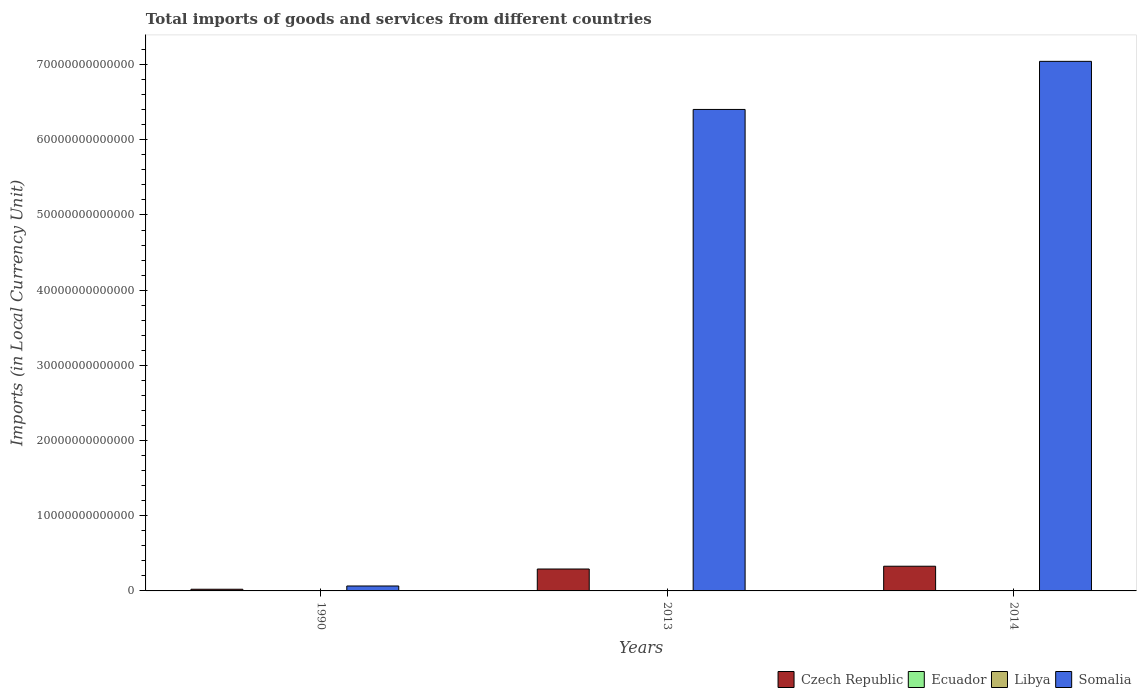How many groups of bars are there?
Provide a short and direct response. 3. Are the number of bars per tick equal to the number of legend labels?
Ensure brevity in your answer.  Yes. In how many cases, is the number of bars for a given year not equal to the number of legend labels?
Your response must be concise. 0. What is the Amount of goods and services imports in Libya in 2014?
Make the answer very short. 5.07e+1. Across all years, what is the maximum Amount of goods and services imports in Czech Republic?
Your answer should be compact. 3.29e+12. Across all years, what is the minimum Amount of goods and services imports in Libya?
Provide a succinct answer. 2.55e+09. In which year was the Amount of goods and services imports in Somalia maximum?
Offer a very short reply. 2014. What is the total Amount of goods and services imports in Czech Republic in the graph?
Your answer should be very brief. 6.42e+12. What is the difference between the Amount of goods and services imports in Somalia in 2013 and that in 2014?
Give a very brief answer. -6.40e+12. What is the difference between the Amount of goods and services imports in Libya in 2014 and the Amount of goods and services imports in Ecuador in 2013?
Provide a short and direct response. 2.08e+1. What is the average Amount of goods and services imports in Ecuador per year?
Provide a succinct answer. 2.12e+1. In the year 2013, what is the difference between the Amount of goods and services imports in Czech Republic and Amount of goods and services imports in Libya?
Provide a succinct answer. 2.86e+12. What is the ratio of the Amount of goods and services imports in Libya in 1990 to that in 2013?
Provide a short and direct response. 0.05. Is the Amount of goods and services imports in Libya in 2013 less than that in 2014?
Give a very brief answer. No. Is the difference between the Amount of goods and services imports in Czech Republic in 1990 and 2013 greater than the difference between the Amount of goods and services imports in Libya in 1990 and 2013?
Ensure brevity in your answer.  No. What is the difference between the highest and the second highest Amount of goods and services imports in Ecuador?
Your answer should be compact. 5.09e+08. What is the difference between the highest and the lowest Amount of goods and services imports in Somalia?
Ensure brevity in your answer.  6.98e+13. In how many years, is the Amount of goods and services imports in Libya greater than the average Amount of goods and services imports in Libya taken over all years?
Your response must be concise. 2. Is it the case that in every year, the sum of the Amount of goods and services imports in Czech Republic and Amount of goods and services imports in Libya is greater than the sum of Amount of goods and services imports in Ecuador and Amount of goods and services imports in Somalia?
Provide a succinct answer. Yes. What does the 3rd bar from the left in 2013 represents?
Offer a very short reply. Libya. What does the 2nd bar from the right in 2014 represents?
Your answer should be compact. Libya. How many bars are there?
Provide a short and direct response. 12. Are all the bars in the graph horizontal?
Offer a very short reply. No. How many years are there in the graph?
Your response must be concise. 3. What is the difference between two consecutive major ticks on the Y-axis?
Ensure brevity in your answer.  1.00e+13. Does the graph contain grids?
Provide a succinct answer. No. Where does the legend appear in the graph?
Offer a terse response. Bottom right. How many legend labels are there?
Provide a short and direct response. 4. What is the title of the graph?
Offer a terse response. Total imports of goods and services from different countries. Does "Syrian Arab Republic" appear as one of the legend labels in the graph?
Provide a succinct answer. No. What is the label or title of the Y-axis?
Make the answer very short. Imports (in Local Currency Unit). What is the Imports (in Local Currency Unit) in Czech Republic in 1990?
Your answer should be very brief. 2.23e+11. What is the Imports (in Local Currency Unit) in Ecuador in 1990?
Ensure brevity in your answer.  3.33e+09. What is the Imports (in Local Currency Unit) in Libya in 1990?
Keep it short and to the point. 2.55e+09. What is the Imports (in Local Currency Unit) of Somalia in 1990?
Keep it short and to the point. 6.56e+11. What is the Imports (in Local Currency Unit) in Czech Republic in 2013?
Keep it short and to the point. 2.91e+12. What is the Imports (in Local Currency Unit) in Ecuador in 2013?
Provide a short and direct response. 2.99e+1. What is the Imports (in Local Currency Unit) of Libya in 2013?
Make the answer very short. 5.40e+1. What is the Imports (in Local Currency Unit) in Somalia in 2013?
Your response must be concise. 6.40e+13. What is the Imports (in Local Currency Unit) in Czech Republic in 2014?
Provide a succinct answer. 3.29e+12. What is the Imports (in Local Currency Unit) in Ecuador in 2014?
Offer a terse response. 3.04e+1. What is the Imports (in Local Currency Unit) of Libya in 2014?
Your answer should be very brief. 5.07e+1. What is the Imports (in Local Currency Unit) in Somalia in 2014?
Ensure brevity in your answer.  7.04e+13. Across all years, what is the maximum Imports (in Local Currency Unit) in Czech Republic?
Give a very brief answer. 3.29e+12. Across all years, what is the maximum Imports (in Local Currency Unit) in Ecuador?
Your response must be concise. 3.04e+1. Across all years, what is the maximum Imports (in Local Currency Unit) of Libya?
Offer a terse response. 5.40e+1. Across all years, what is the maximum Imports (in Local Currency Unit) in Somalia?
Ensure brevity in your answer.  7.04e+13. Across all years, what is the minimum Imports (in Local Currency Unit) in Czech Republic?
Provide a short and direct response. 2.23e+11. Across all years, what is the minimum Imports (in Local Currency Unit) in Ecuador?
Make the answer very short. 3.33e+09. Across all years, what is the minimum Imports (in Local Currency Unit) in Libya?
Your answer should be compact. 2.55e+09. Across all years, what is the minimum Imports (in Local Currency Unit) of Somalia?
Offer a terse response. 6.56e+11. What is the total Imports (in Local Currency Unit) in Czech Republic in the graph?
Your answer should be very brief. 6.42e+12. What is the total Imports (in Local Currency Unit) in Ecuador in the graph?
Provide a short and direct response. 6.36e+1. What is the total Imports (in Local Currency Unit) in Libya in the graph?
Provide a succinct answer. 1.07e+11. What is the total Imports (in Local Currency Unit) of Somalia in the graph?
Make the answer very short. 1.35e+14. What is the difference between the Imports (in Local Currency Unit) in Czech Republic in 1990 and that in 2013?
Your answer should be compact. -2.69e+12. What is the difference between the Imports (in Local Currency Unit) in Ecuador in 1990 and that in 2013?
Provide a succinct answer. -2.65e+1. What is the difference between the Imports (in Local Currency Unit) in Libya in 1990 and that in 2013?
Keep it short and to the point. -5.15e+1. What is the difference between the Imports (in Local Currency Unit) of Somalia in 1990 and that in 2013?
Make the answer very short. -6.34e+13. What is the difference between the Imports (in Local Currency Unit) of Czech Republic in 1990 and that in 2014?
Give a very brief answer. -3.06e+12. What is the difference between the Imports (in Local Currency Unit) of Ecuador in 1990 and that in 2014?
Make the answer very short. -2.71e+1. What is the difference between the Imports (in Local Currency Unit) of Libya in 1990 and that in 2014?
Offer a very short reply. -4.82e+1. What is the difference between the Imports (in Local Currency Unit) in Somalia in 1990 and that in 2014?
Keep it short and to the point. -6.98e+13. What is the difference between the Imports (in Local Currency Unit) of Czech Republic in 2013 and that in 2014?
Make the answer very short. -3.71e+11. What is the difference between the Imports (in Local Currency Unit) of Ecuador in 2013 and that in 2014?
Provide a succinct answer. -5.09e+08. What is the difference between the Imports (in Local Currency Unit) in Libya in 2013 and that in 2014?
Offer a terse response. 3.29e+09. What is the difference between the Imports (in Local Currency Unit) of Somalia in 2013 and that in 2014?
Your answer should be compact. -6.40e+12. What is the difference between the Imports (in Local Currency Unit) in Czech Republic in 1990 and the Imports (in Local Currency Unit) in Ecuador in 2013?
Offer a very short reply. 1.93e+11. What is the difference between the Imports (in Local Currency Unit) of Czech Republic in 1990 and the Imports (in Local Currency Unit) of Libya in 2013?
Keep it short and to the point. 1.69e+11. What is the difference between the Imports (in Local Currency Unit) of Czech Republic in 1990 and the Imports (in Local Currency Unit) of Somalia in 2013?
Give a very brief answer. -6.38e+13. What is the difference between the Imports (in Local Currency Unit) of Ecuador in 1990 and the Imports (in Local Currency Unit) of Libya in 2013?
Offer a very short reply. -5.07e+1. What is the difference between the Imports (in Local Currency Unit) in Ecuador in 1990 and the Imports (in Local Currency Unit) in Somalia in 2013?
Offer a terse response. -6.40e+13. What is the difference between the Imports (in Local Currency Unit) in Libya in 1990 and the Imports (in Local Currency Unit) in Somalia in 2013?
Provide a succinct answer. -6.40e+13. What is the difference between the Imports (in Local Currency Unit) of Czech Republic in 1990 and the Imports (in Local Currency Unit) of Ecuador in 2014?
Offer a terse response. 1.93e+11. What is the difference between the Imports (in Local Currency Unit) in Czech Republic in 1990 and the Imports (in Local Currency Unit) in Libya in 2014?
Your answer should be compact. 1.73e+11. What is the difference between the Imports (in Local Currency Unit) in Czech Republic in 1990 and the Imports (in Local Currency Unit) in Somalia in 2014?
Keep it short and to the point. -7.02e+13. What is the difference between the Imports (in Local Currency Unit) in Ecuador in 1990 and the Imports (in Local Currency Unit) in Libya in 2014?
Offer a terse response. -4.74e+1. What is the difference between the Imports (in Local Currency Unit) of Ecuador in 1990 and the Imports (in Local Currency Unit) of Somalia in 2014?
Ensure brevity in your answer.  -7.04e+13. What is the difference between the Imports (in Local Currency Unit) of Libya in 1990 and the Imports (in Local Currency Unit) of Somalia in 2014?
Ensure brevity in your answer.  -7.04e+13. What is the difference between the Imports (in Local Currency Unit) of Czech Republic in 2013 and the Imports (in Local Currency Unit) of Ecuador in 2014?
Ensure brevity in your answer.  2.88e+12. What is the difference between the Imports (in Local Currency Unit) in Czech Republic in 2013 and the Imports (in Local Currency Unit) in Libya in 2014?
Your answer should be compact. 2.86e+12. What is the difference between the Imports (in Local Currency Unit) of Czech Republic in 2013 and the Imports (in Local Currency Unit) of Somalia in 2014?
Make the answer very short. -6.75e+13. What is the difference between the Imports (in Local Currency Unit) of Ecuador in 2013 and the Imports (in Local Currency Unit) of Libya in 2014?
Provide a short and direct response. -2.08e+1. What is the difference between the Imports (in Local Currency Unit) in Ecuador in 2013 and the Imports (in Local Currency Unit) in Somalia in 2014?
Keep it short and to the point. -7.04e+13. What is the difference between the Imports (in Local Currency Unit) of Libya in 2013 and the Imports (in Local Currency Unit) of Somalia in 2014?
Your answer should be compact. -7.04e+13. What is the average Imports (in Local Currency Unit) of Czech Republic per year?
Provide a short and direct response. 2.14e+12. What is the average Imports (in Local Currency Unit) in Ecuador per year?
Offer a very short reply. 2.12e+1. What is the average Imports (in Local Currency Unit) in Libya per year?
Your response must be concise. 3.58e+1. What is the average Imports (in Local Currency Unit) in Somalia per year?
Your answer should be very brief. 4.50e+13. In the year 1990, what is the difference between the Imports (in Local Currency Unit) of Czech Republic and Imports (in Local Currency Unit) of Ecuador?
Provide a short and direct response. 2.20e+11. In the year 1990, what is the difference between the Imports (in Local Currency Unit) in Czech Republic and Imports (in Local Currency Unit) in Libya?
Give a very brief answer. 2.21e+11. In the year 1990, what is the difference between the Imports (in Local Currency Unit) in Czech Republic and Imports (in Local Currency Unit) in Somalia?
Your answer should be very brief. -4.33e+11. In the year 1990, what is the difference between the Imports (in Local Currency Unit) of Ecuador and Imports (in Local Currency Unit) of Libya?
Ensure brevity in your answer.  7.78e+08. In the year 1990, what is the difference between the Imports (in Local Currency Unit) in Ecuador and Imports (in Local Currency Unit) in Somalia?
Keep it short and to the point. -6.53e+11. In the year 1990, what is the difference between the Imports (in Local Currency Unit) of Libya and Imports (in Local Currency Unit) of Somalia?
Make the answer very short. -6.54e+11. In the year 2013, what is the difference between the Imports (in Local Currency Unit) of Czech Republic and Imports (in Local Currency Unit) of Ecuador?
Ensure brevity in your answer.  2.88e+12. In the year 2013, what is the difference between the Imports (in Local Currency Unit) of Czech Republic and Imports (in Local Currency Unit) of Libya?
Your answer should be compact. 2.86e+12. In the year 2013, what is the difference between the Imports (in Local Currency Unit) of Czech Republic and Imports (in Local Currency Unit) of Somalia?
Provide a short and direct response. -6.11e+13. In the year 2013, what is the difference between the Imports (in Local Currency Unit) of Ecuador and Imports (in Local Currency Unit) of Libya?
Provide a short and direct response. -2.41e+1. In the year 2013, what is the difference between the Imports (in Local Currency Unit) of Ecuador and Imports (in Local Currency Unit) of Somalia?
Offer a terse response. -6.40e+13. In the year 2013, what is the difference between the Imports (in Local Currency Unit) of Libya and Imports (in Local Currency Unit) of Somalia?
Provide a short and direct response. -6.40e+13. In the year 2014, what is the difference between the Imports (in Local Currency Unit) in Czech Republic and Imports (in Local Currency Unit) in Ecuador?
Your response must be concise. 3.25e+12. In the year 2014, what is the difference between the Imports (in Local Currency Unit) of Czech Republic and Imports (in Local Currency Unit) of Libya?
Give a very brief answer. 3.23e+12. In the year 2014, what is the difference between the Imports (in Local Currency Unit) in Czech Republic and Imports (in Local Currency Unit) in Somalia?
Ensure brevity in your answer.  -6.71e+13. In the year 2014, what is the difference between the Imports (in Local Currency Unit) in Ecuador and Imports (in Local Currency Unit) in Libya?
Give a very brief answer. -2.03e+1. In the year 2014, what is the difference between the Imports (in Local Currency Unit) of Ecuador and Imports (in Local Currency Unit) of Somalia?
Make the answer very short. -7.04e+13. In the year 2014, what is the difference between the Imports (in Local Currency Unit) of Libya and Imports (in Local Currency Unit) of Somalia?
Your answer should be very brief. -7.04e+13. What is the ratio of the Imports (in Local Currency Unit) in Czech Republic in 1990 to that in 2013?
Make the answer very short. 0.08. What is the ratio of the Imports (in Local Currency Unit) in Ecuador in 1990 to that in 2013?
Your response must be concise. 0.11. What is the ratio of the Imports (in Local Currency Unit) in Libya in 1990 to that in 2013?
Offer a very short reply. 0.05. What is the ratio of the Imports (in Local Currency Unit) in Somalia in 1990 to that in 2013?
Provide a short and direct response. 0.01. What is the ratio of the Imports (in Local Currency Unit) of Czech Republic in 1990 to that in 2014?
Ensure brevity in your answer.  0.07. What is the ratio of the Imports (in Local Currency Unit) of Ecuador in 1990 to that in 2014?
Your answer should be compact. 0.11. What is the ratio of the Imports (in Local Currency Unit) in Libya in 1990 to that in 2014?
Offer a terse response. 0.05. What is the ratio of the Imports (in Local Currency Unit) in Somalia in 1990 to that in 2014?
Ensure brevity in your answer.  0.01. What is the ratio of the Imports (in Local Currency Unit) of Czech Republic in 2013 to that in 2014?
Ensure brevity in your answer.  0.89. What is the ratio of the Imports (in Local Currency Unit) of Ecuador in 2013 to that in 2014?
Provide a short and direct response. 0.98. What is the ratio of the Imports (in Local Currency Unit) of Libya in 2013 to that in 2014?
Offer a terse response. 1.06. What is the ratio of the Imports (in Local Currency Unit) of Somalia in 2013 to that in 2014?
Your answer should be very brief. 0.91. What is the difference between the highest and the second highest Imports (in Local Currency Unit) of Czech Republic?
Your response must be concise. 3.71e+11. What is the difference between the highest and the second highest Imports (in Local Currency Unit) in Ecuador?
Your answer should be compact. 5.09e+08. What is the difference between the highest and the second highest Imports (in Local Currency Unit) in Libya?
Give a very brief answer. 3.29e+09. What is the difference between the highest and the second highest Imports (in Local Currency Unit) of Somalia?
Make the answer very short. 6.40e+12. What is the difference between the highest and the lowest Imports (in Local Currency Unit) in Czech Republic?
Provide a short and direct response. 3.06e+12. What is the difference between the highest and the lowest Imports (in Local Currency Unit) in Ecuador?
Ensure brevity in your answer.  2.71e+1. What is the difference between the highest and the lowest Imports (in Local Currency Unit) in Libya?
Provide a short and direct response. 5.15e+1. What is the difference between the highest and the lowest Imports (in Local Currency Unit) in Somalia?
Ensure brevity in your answer.  6.98e+13. 